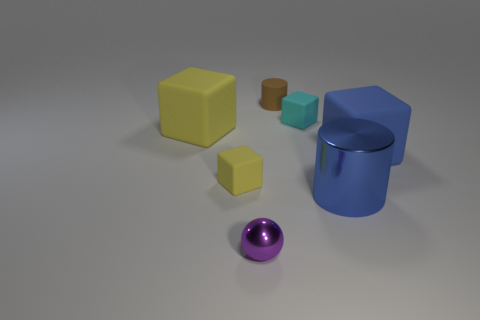What is the size of the blue cylinder?
Make the answer very short. Large. There is a large thing that is the same color as the large cylinder; what is it made of?
Provide a succinct answer. Rubber. How many large rubber objects have the same color as the big shiny cylinder?
Offer a very short reply. 1. Do the brown rubber cylinder and the cyan matte thing have the same size?
Your answer should be compact. Yes. What is the size of the cylinder behind the large matte object to the right of the large yellow matte cube?
Your answer should be very brief. Small. There is a big metal thing; does it have the same color as the matte cube on the right side of the blue metal object?
Provide a short and direct response. Yes. Is there another cyan thing that has the same size as the cyan matte object?
Keep it short and to the point. No. There is a cylinder on the right side of the cyan matte cube; what size is it?
Provide a short and direct response. Large. There is a tiny matte object on the left side of the small metallic thing; is there a rubber object in front of it?
Your answer should be very brief. No. How many other objects are there of the same shape as the small brown thing?
Offer a terse response. 1. 